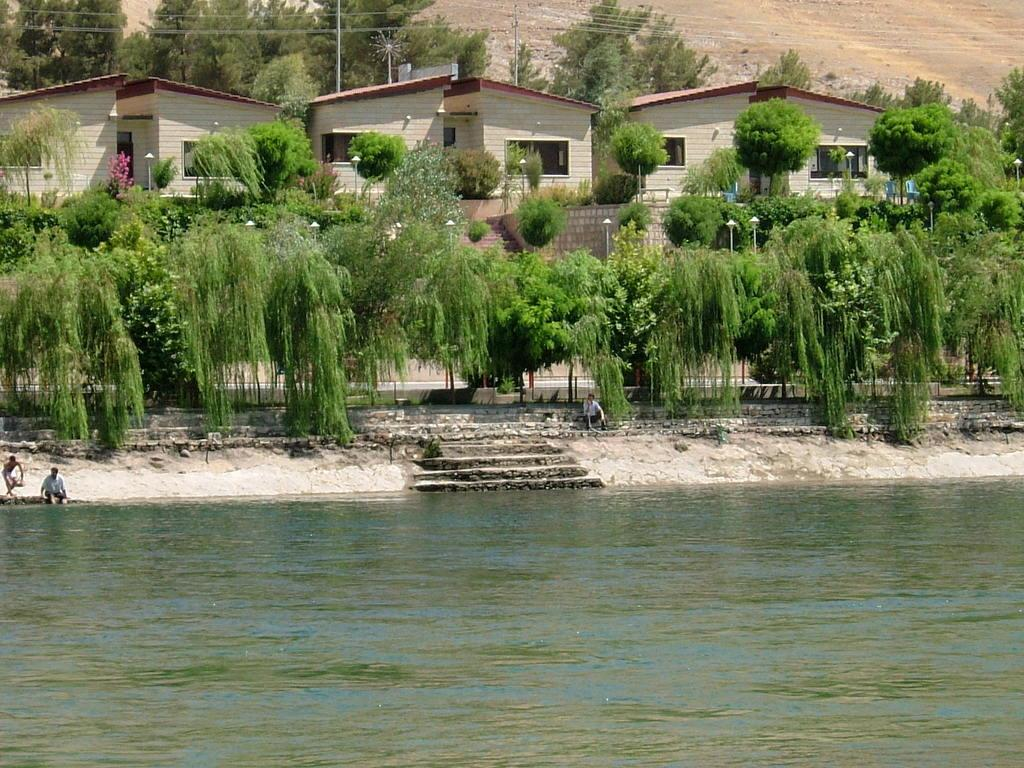What is located in the foreground of the image? There is a water body in the foreground of the image. What can be seen in the background of the image? There are buildings and trees in the background of the image. Are there any architectural features in the image? Yes, there are stairs in the image. What are the people near the water body doing? The people are sitting near the water body. What type of tin can be seen near the house in the image? There is no tin or house present in the image. How many chairs are visible in the image? There are no chairs visible in the image. 